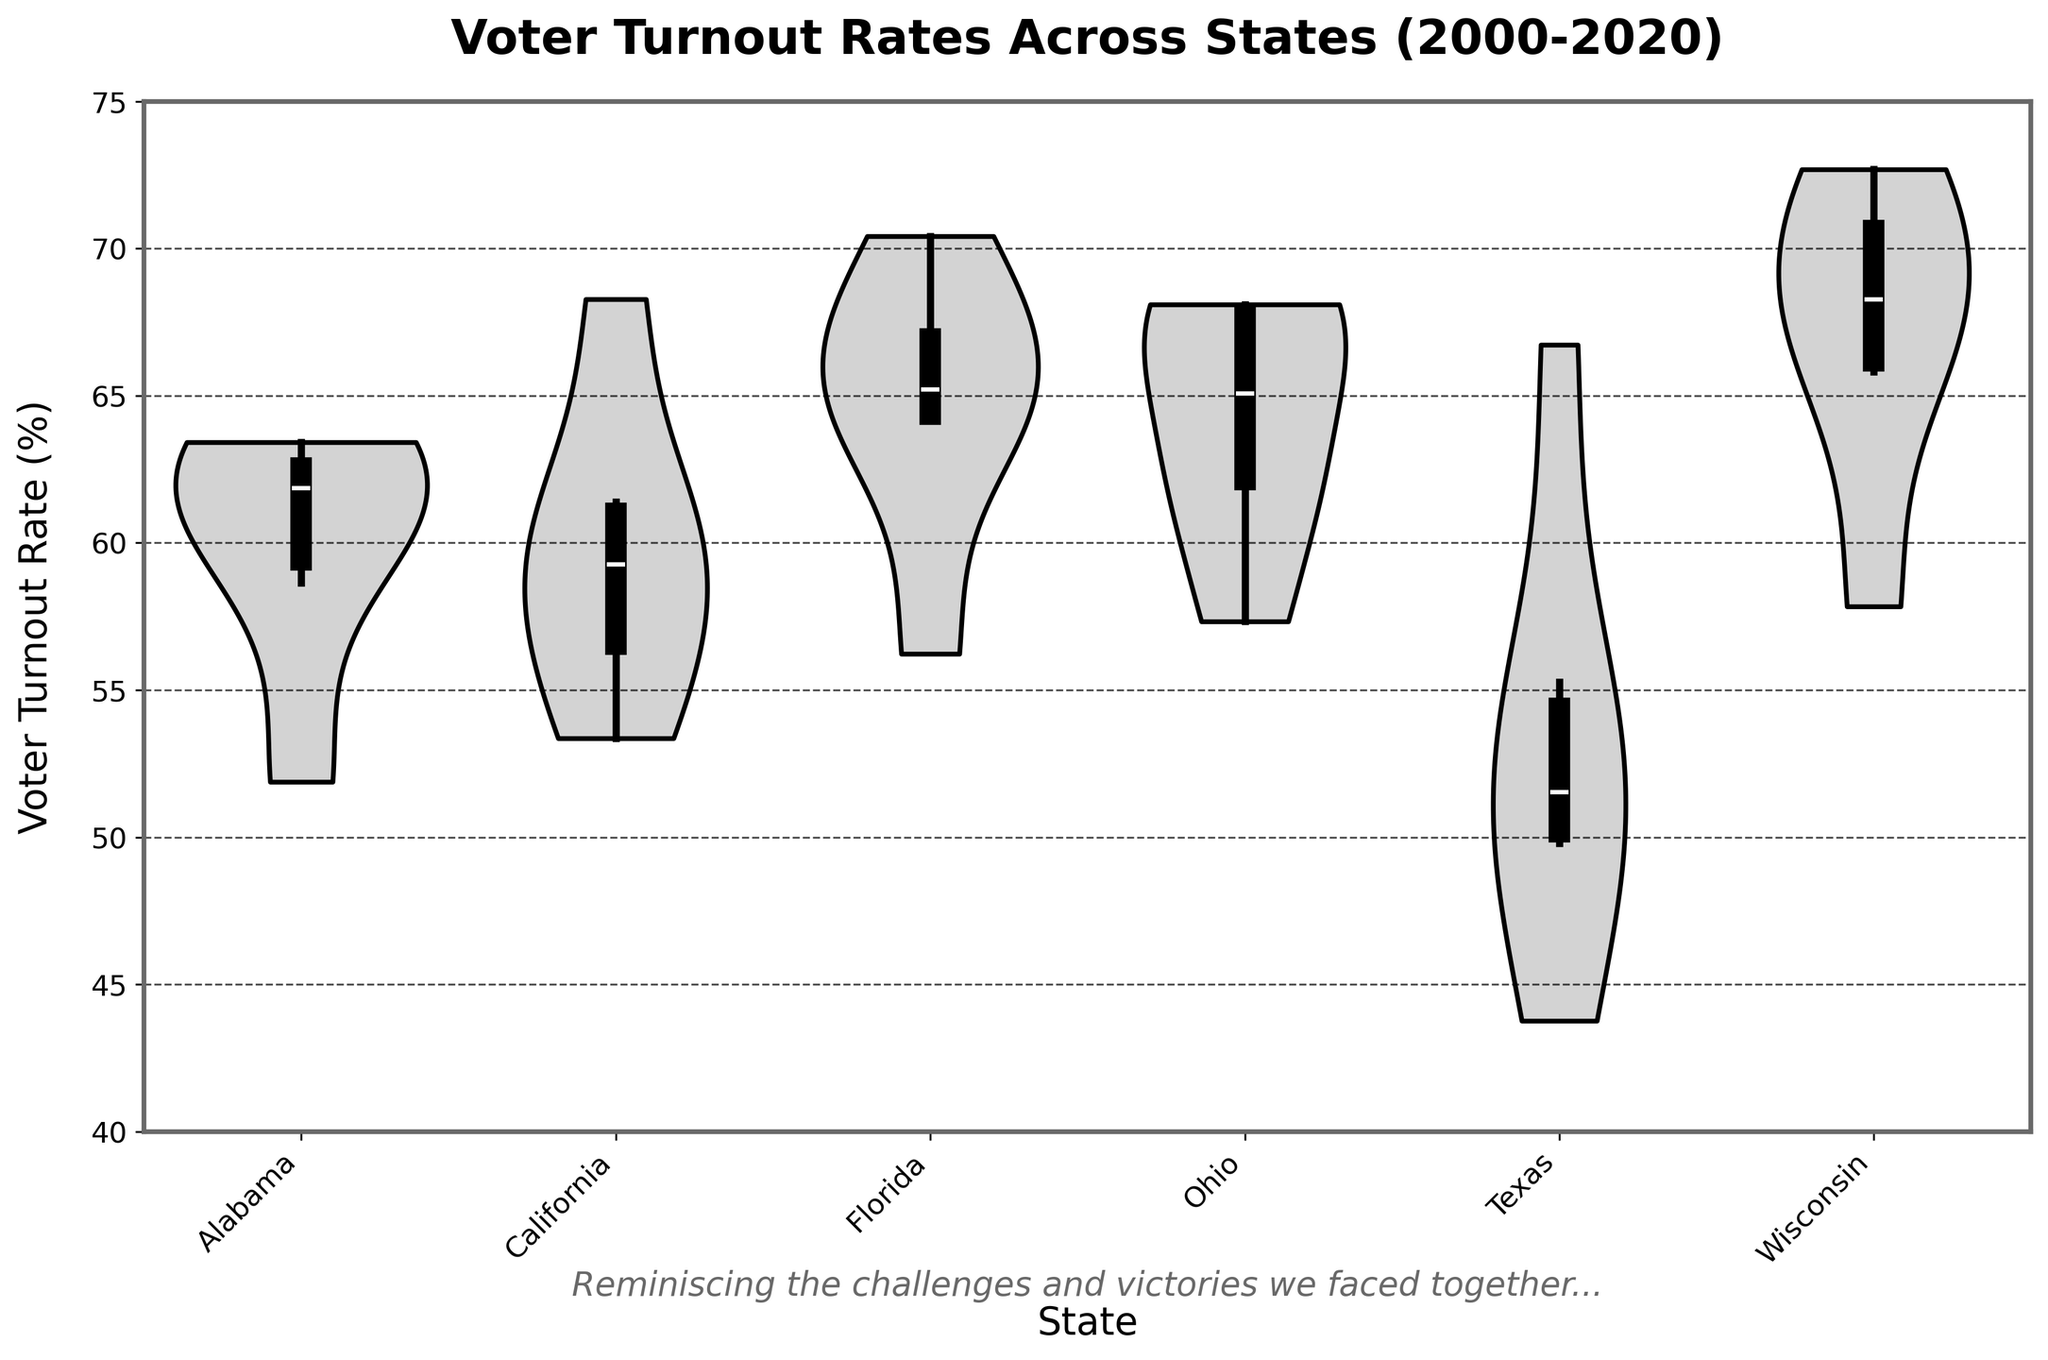What is the title of the figure? The title is usually displayed at the top of the chart and is written in large, bold text. It provides a brief description of what the chart represents.
Answer: Voter Turnout Rates Across States (2000-2020) What is the minimum voter turnout rate shown on the chart? The minimum voter turnout rate is the lowest point on the y-axis, which is indicated by the edge of the violin plot.
Answer: 40% Which state had the highest median voter turnout rate from 2000 to 2020? The median turnout rate is indicated by the thick black bar inside each violin plot. The state with the median value furthest up the y-axis has the highest median turnout rate.
Answer: Wisconsin How does Florida's voter turnout rate compare to Texas's voter turnout rate in 2020? Look at the respective points in the violin plots for Florida and Texas in 2020. Florida has a higher turnout rate for 2020.
Answer: Florida is higher Which state shows the greatest variance in voter turnout rates? Variance can be visualized by the width of the violin plot. The wider the plot, the greater the variance.
Answer: Wisconsin Did any state have a voter turnout rate over 70% in any election year? Check for any points or sections of the violin plots that extend beyond the 70% mark on the y-axis.
Answer: Yes What is the range of voter turnout rates for California? The range can be determined by the difference between the maximum and minimum values within the violin plot for California.
Answer: 53.36% to 68.28% Between which years did Ohio see the largest increase in voter turnout? Compare the voter turnout rates shown at different points in the violin plot for Ohio, focusing on year-to-year changes.
Answer: 2000 to 2004 Identify the year with the highest turnout rate in Wisconsin. Look for the highest point within Wisconsin's violin plot. The corresponding year is the one with the highest turnout.
Answer: 2020 Which state had the lowest voter turnout rate in 2012? Check the tips of the violin plots for each state within the specific segment for 2012 and find the lowest point.
Answer: Texas 